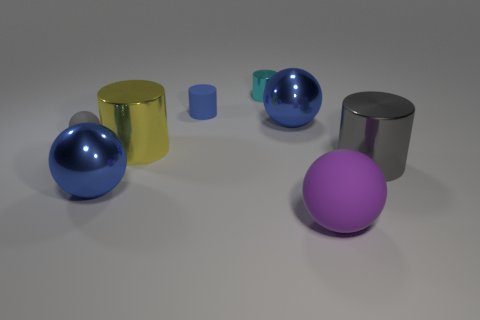Subtract all small gray matte balls. How many balls are left? 3 Add 1 large blue balls. How many objects exist? 9 Subtract all yellow cylinders. How many cylinders are left? 3 Subtract 2 cylinders. How many cylinders are left? 2 Subtract all gray cylinders. Subtract all blue spheres. How many cylinders are left? 3 Subtract all red cylinders. How many blue spheres are left? 2 Subtract all big green blocks. Subtract all purple rubber objects. How many objects are left? 7 Add 8 small gray things. How many small gray things are left? 9 Add 5 blue metallic spheres. How many blue metallic spheres exist? 7 Subtract 1 blue balls. How many objects are left? 7 